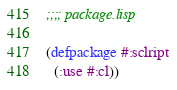<code> <loc_0><loc_0><loc_500><loc_500><_Lisp_>;;;; package.lisp

(defpackage #:sclript
  (:use #:cl))
</code> 